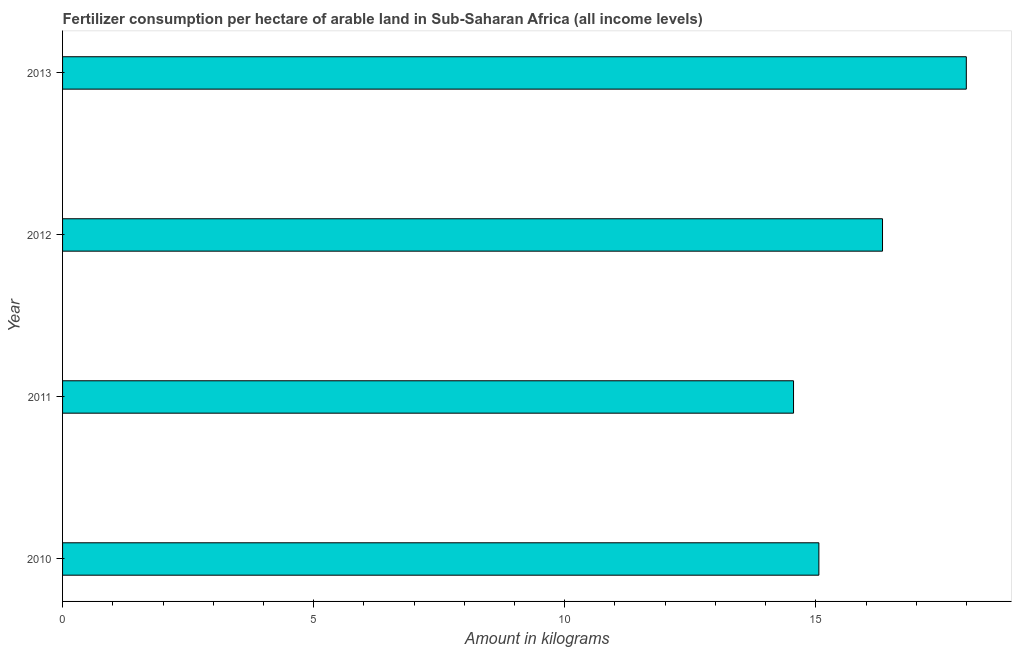Does the graph contain any zero values?
Keep it short and to the point. No. Does the graph contain grids?
Keep it short and to the point. No. What is the title of the graph?
Offer a very short reply. Fertilizer consumption per hectare of arable land in Sub-Saharan Africa (all income levels) . What is the label or title of the X-axis?
Provide a succinct answer. Amount in kilograms. What is the amount of fertilizer consumption in 2013?
Your response must be concise. 18. Across all years, what is the maximum amount of fertilizer consumption?
Provide a succinct answer. 18. Across all years, what is the minimum amount of fertilizer consumption?
Ensure brevity in your answer.  14.56. In which year was the amount of fertilizer consumption minimum?
Offer a very short reply. 2011. What is the sum of the amount of fertilizer consumption?
Offer a terse response. 63.94. What is the difference between the amount of fertilizer consumption in 2012 and 2013?
Ensure brevity in your answer.  -1.67. What is the average amount of fertilizer consumption per year?
Your response must be concise. 15.99. What is the median amount of fertilizer consumption?
Make the answer very short. 15.69. What is the ratio of the amount of fertilizer consumption in 2012 to that in 2013?
Offer a terse response. 0.91. Is the amount of fertilizer consumption in 2011 less than that in 2012?
Offer a terse response. Yes. Is the difference between the amount of fertilizer consumption in 2011 and 2013 greater than the difference between any two years?
Provide a short and direct response. Yes. What is the difference between the highest and the second highest amount of fertilizer consumption?
Give a very brief answer. 1.67. What is the difference between the highest and the lowest amount of fertilizer consumption?
Make the answer very short. 3.44. How many bars are there?
Provide a succinct answer. 4. Are all the bars in the graph horizontal?
Your answer should be very brief. Yes. How many years are there in the graph?
Provide a succinct answer. 4. Are the values on the major ticks of X-axis written in scientific E-notation?
Your response must be concise. No. What is the Amount in kilograms of 2010?
Your answer should be compact. 15.06. What is the Amount in kilograms in 2011?
Your response must be concise. 14.56. What is the Amount in kilograms in 2012?
Make the answer very short. 16.33. What is the Amount in kilograms of 2013?
Offer a very short reply. 18. What is the difference between the Amount in kilograms in 2010 and 2011?
Provide a short and direct response. 0.5. What is the difference between the Amount in kilograms in 2010 and 2012?
Your response must be concise. -1.27. What is the difference between the Amount in kilograms in 2010 and 2013?
Your answer should be very brief. -2.94. What is the difference between the Amount in kilograms in 2011 and 2012?
Provide a short and direct response. -1.77. What is the difference between the Amount in kilograms in 2011 and 2013?
Your response must be concise. -3.44. What is the difference between the Amount in kilograms in 2012 and 2013?
Keep it short and to the point. -1.67. What is the ratio of the Amount in kilograms in 2010 to that in 2011?
Provide a succinct answer. 1.03. What is the ratio of the Amount in kilograms in 2010 to that in 2012?
Your answer should be compact. 0.92. What is the ratio of the Amount in kilograms in 2010 to that in 2013?
Provide a short and direct response. 0.84. What is the ratio of the Amount in kilograms in 2011 to that in 2012?
Give a very brief answer. 0.89. What is the ratio of the Amount in kilograms in 2011 to that in 2013?
Your answer should be very brief. 0.81. What is the ratio of the Amount in kilograms in 2012 to that in 2013?
Give a very brief answer. 0.91. 